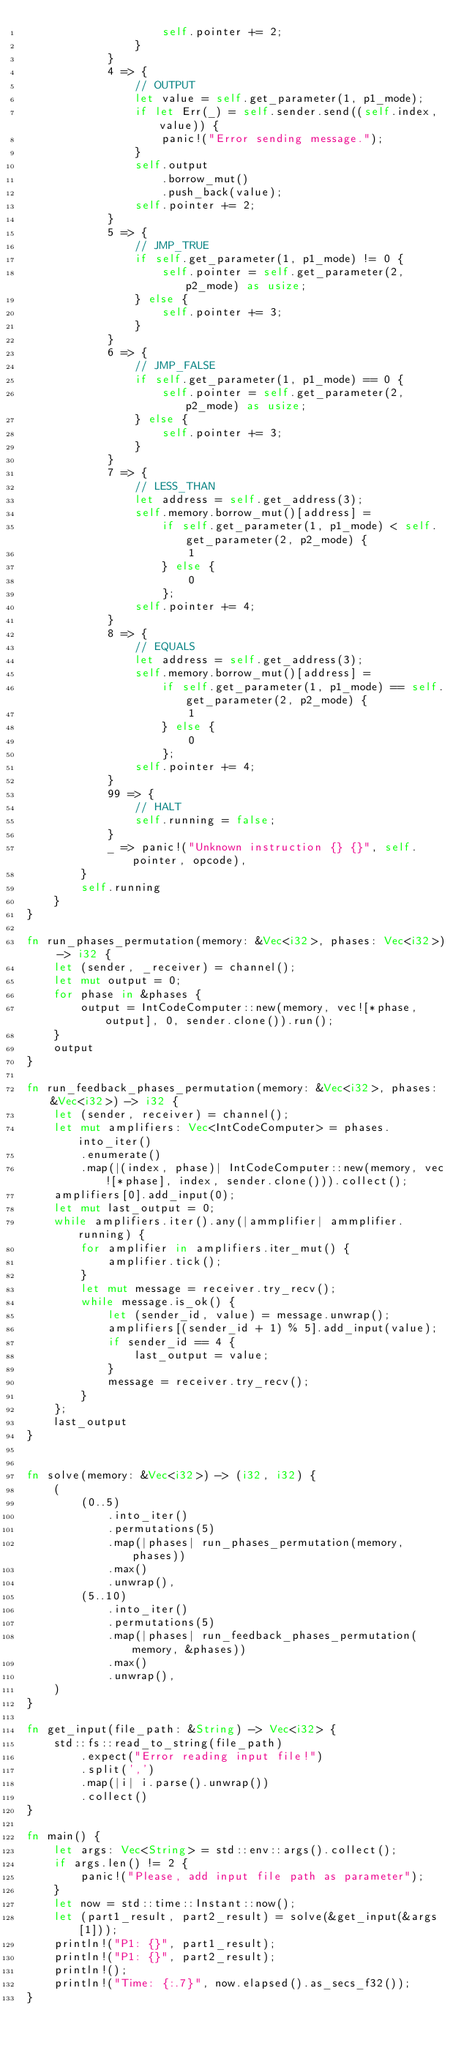<code> <loc_0><loc_0><loc_500><loc_500><_Rust_>                    self.pointer += 2;
                }
            }
            4 => {
                // OUTPUT
                let value = self.get_parameter(1, p1_mode);
                if let Err(_) = self.sender.send((self.index, value)) {
                    panic!("Error sending message.");
                }
                self.output
                    .borrow_mut()
                    .push_back(value);
                self.pointer += 2;
            }
            5 => {
                // JMP_TRUE
                if self.get_parameter(1, p1_mode) != 0 {
                    self.pointer = self.get_parameter(2, p2_mode) as usize;
                } else {
                    self.pointer += 3;
                }
            }
            6 => {
                // JMP_FALSE
                if self.get_parameter(1, p1_mode) == 0 {
                    self.pointer = self.get_parameter(2, p2_mode) as usize;
                } else {
                    self.pointer += 3;
                }
            }
            7 => {
                // LESS_THAN
                let address = self.get_address(3);
                self.memory.borrow_mut()[address] =
                    if self.get_parameter(1, p1_mode) < self.get_parameter(2, p2_mode) {
                        1
                    } else {
                        0
                    };
                self.pointer += 4;
            }
            8 => {
                // EQUALS
                let address = self.get_address(3);
                self.memory.borrow_mut()[address] =
                    if self.get_parameter(1, p1_mode) == self.get_parameter(2, p2_mode) {
                        1
                    } else {
                        0
                    };
                self.pointer += 4;
            }
            99 => {
                // HALT
                self.running = false;
            }
            _ => panic!("Unknown instruction {} {}", self.pointer, opcode),
        }
        self.running
    }
}

fn run_phases_permutation(memory: &Vec<i32>, phases: Vec<i32>) -> i32 {
    let (sender, _receiver) = channel();
    let mut output = 0;
    for phase in &phases {
        output = IntCodeComputer::new(memory, vec![*phase, output], 0, sender.clone()).run();
    }
    output
}

fn run_feedback_phases_permutation(memory: &Vec<i32>, phases: &Vec<i32>) -> i32 {
    let (sender, receiver) = channel();
    let mut amplifiers: Vec<IntCodeComputer> = phases.into_iter()
        .enumerate()
        .map(|(index, phase)| IntCodeComputer::new(memory, vec![*phase], index, sender.clone())).collect();
    amplifiers[0].add_input(0);
    let mut last_output = 0;
    while amplifiers.iter().any(|ammplifier| ammplifier.running) {
        for amplifier in amplifiers.iter_mut() {
            amplifier.tick();
        }
        let mut message = receiver.try_recv();
        while message.is_ok() {
            let (sender_id, value) = message.unwrap();
            amplifiers[(sender_id + 1) % 5].add_input(value);
            if sender_id == 4 {
                last_output = value;
            }
            message = receiver.try_recv();
        }
    };
    last_output
}


fn solve(memory: &Vec<i32>) -> (i32, i32) {
    (
        (0..5)
            .into_iter()
            .permutations(5)
            .map(|phases| run_phases_permutation(memory, phases))
            .max()
            .unwrap(),
        (5..10)
            .into_iter()
            .permutations(5)
            .map(|phases| run_feedback_phases_permutation(memory, &phases))
            .max()
            .unwrap(),
    )
}

fn get_input(file_path: &String) -> Vec<i32> {
    std::fs::read_to_string(file_path)
        .expect("Error reading input file!")
        .split(',')
        .map(|i| i.parse().unwrap())
        .collect()
}

fn main() {
    let args: Vec<String> = std::env::args().collect();
    if args.len() != 2 {
        panic!("Please, add input file path as parameter");
    }
    let now = std::time::Instant::now();
    let (part1_result, part2_result) = solve(&get_input(&args[1]));
    println!("P1: {}", part1_result);
    println!("P1: {}", part2_result);
    println!();
    println!("Time: {:.7}", now.elapsed().as_secs_f32());
}
</code> 